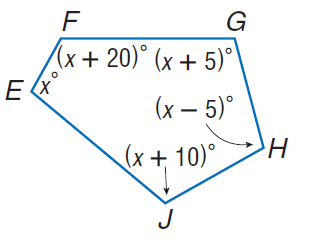Answer the mathemtical geometry problem and directly provide the correct option letter.
Question: Find m \angle E.
Choices: A: 97 B: 102 C: 107 D: 122 B 